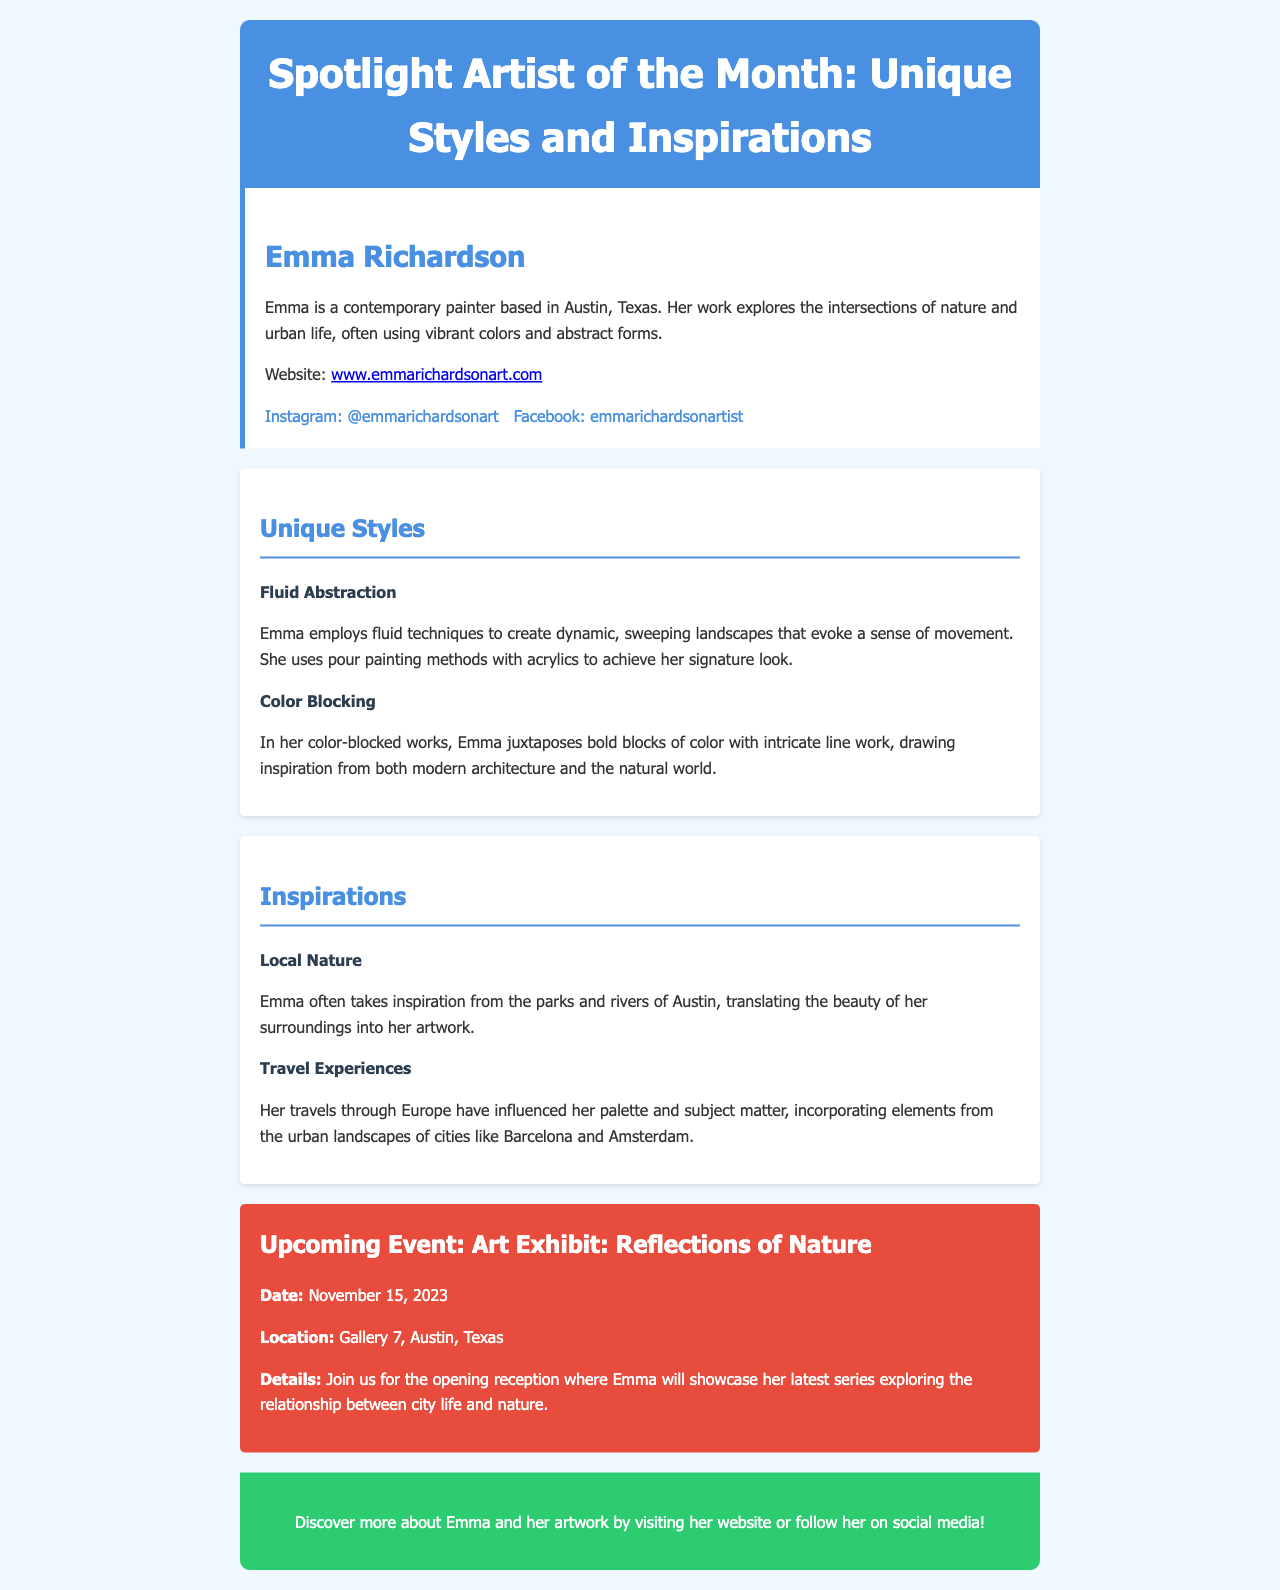What is the name of the artist featured? The featured artist in the document is named Emma Richardson.
Answer: Emma Richardson What city is Emma Richardson based in? The document states that Emma is a contemporary painter based in Austin, Texas.
Answer: Austin, Texas What technique does Emma use for her fluid abstraction style? The document mentions that Emma employs pour painting methods with acrylics to create her fluid abstraction style.
Answer: Pour painting What is the date of the upcoming art exhibit? The document provides the date of the upcoming event as November 15, 2023.
Answer: November 15, 2023 Which city has influenced Emma's palette through her travels? The document states that her travels through Europe have influenced her palette, specifically mentioning cities like Barcelona and Amsterdam.
Answer: Barcelona and Amsterdam What kind of patterns does Emma use in her color-blocked works? The document indicates that in her color-blocked works, Emma juxtaposes bold blocks of color with intricate line work.
Answer: Bold blocks of color and intricate line work What is the title of the upcoming event? The upcoming event's title mentioned in the document is "Art Exhibit: Reflections of Nature."
Answer: Art Exhibit: Reflections of Nature What natural feature does Emma draw inspiration from in Austin? The document states that Emma takes inspiration from the parks and rivers of Austin.
Answer: Parks and rivers What is the main color of the header in the newsletter design? The header background color is specified as #4a90e2 in the design, which corresponds to a shade of blue.
Answer: Blue 